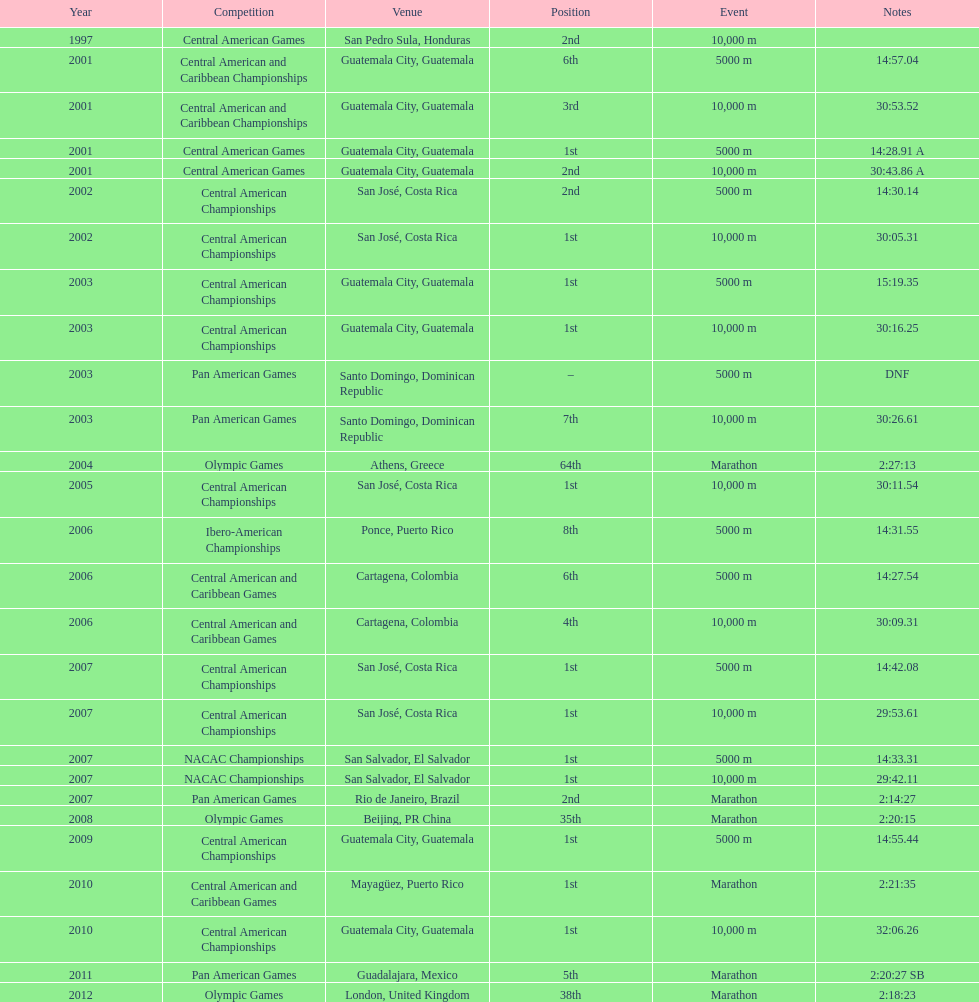Tell me the number of times they competed in guatamala. 5. 